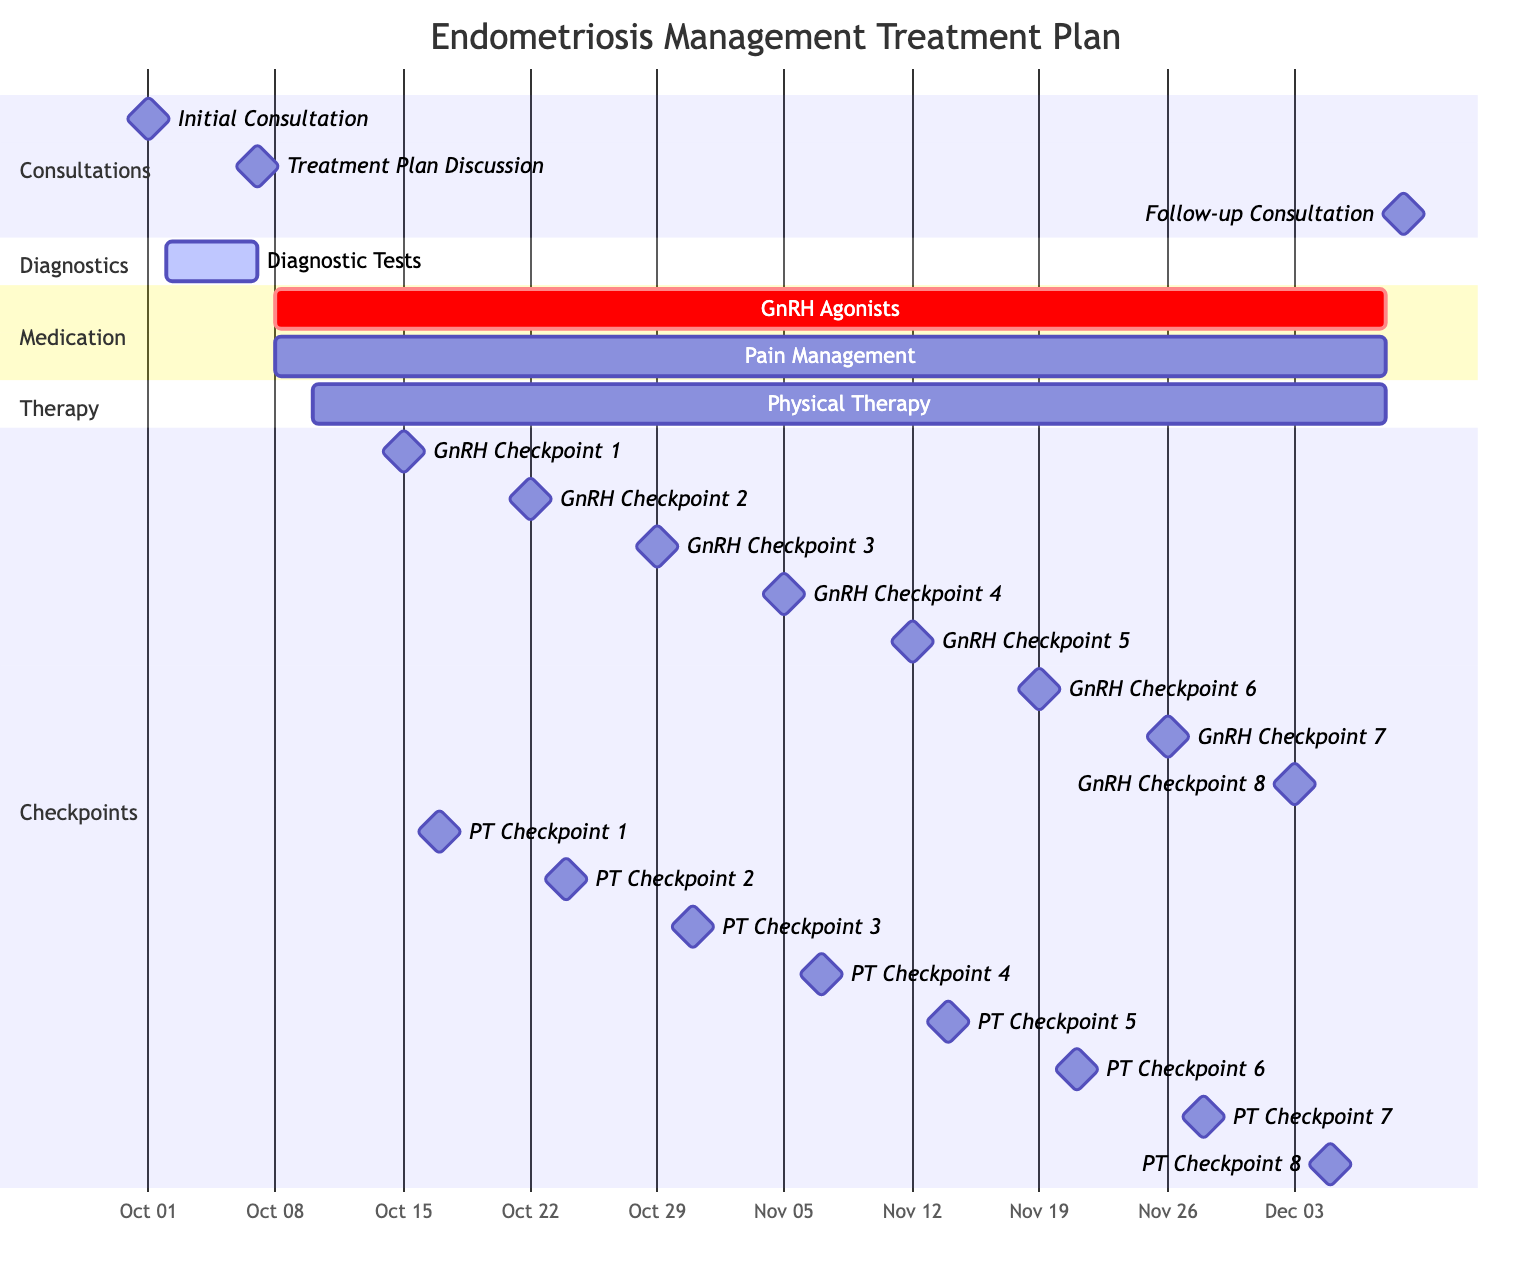What is the duration of the medication task? The medication task starts on October 8, 2023, and ends on December 8, 2023. To find the duration, count the number of days from the start to the end date. This gives a total of 62 days.
Answer: 62 days When does the initial consultation take place? The initial consultation is marked as a milestone point in the diagram. It is set for October 1, 2023, which can be seen directly from the diagram timeline.
Answer: October 1, 2023 How many weekly checkpoints are there for the GnRH agonists? The GnRH agonists have checkpoints listed on specific dates. Counting these dates reveals there are a total of 8 checkpoints throughout the duration of the medication task.
Answer: 8 What is the end date for the physical therapy task? The physical therapy task starts on October 10, 2023, and ends on December 8, 2023. This end date is shown directly on the Gantt chart, marking the conclusion of this activity.
Answer: December 8, 2023 Which task starts after the diagnostic tests? The diagram shows that after the diagnostic tests conclude on October 6, 2023, the next task is the "Treatment Plan Discussion," which occurs on October 7, 2023. This can be visually followed on the chart.
Answer: Treatment Plan Discussion Which two tasks overlap in their timeline? By examining the timeline, both the "Medication - GnRH Agonists" and "Pain Management" tasks start on October 8, 2023, and end on December 8, 2023, indicating they overlap completely.
Answer: Medication - GnRH Agonists and Pain Management What is the primary purpose of the follow-up consultation? The follow-up consultation, marked as a milestone on December 9, 2023, is meant to assess the overall effectiveness of the treatment and discuss any necessary next steps regarding the management of endometriosis based on prior progress.
Answer: Assess effectiveness of treatment How many distinct sections are represented in the Gantt chart? The Gantt chart is divided into four distinct sections: Consultations, Diagnostics, Medication, and Therapy. Each section contains relevant tasks visually represented in the timeline.
Answer: 4 